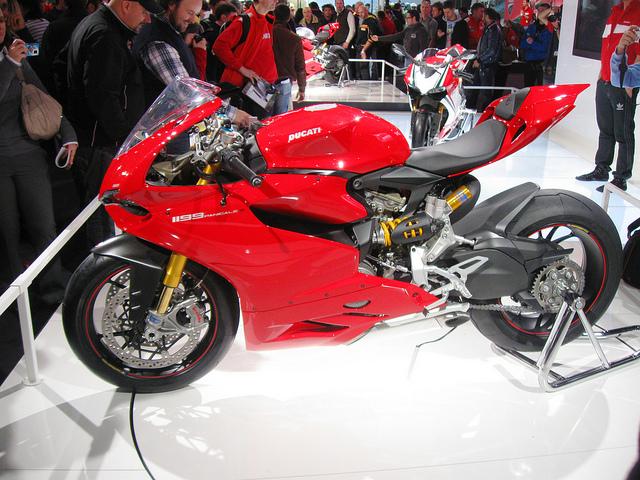What color is the bike?
Be succinct. Red. How many wheels?
Short answer required. 2. What kind of bike is it?
Keep it brief. Motorcycle. 